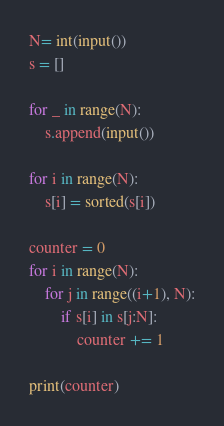Convert code to text. <code><loc_0><loc_0><loc_500><loc_500><_Python_>N= int(input())
s = []

for _ in range(N):
    s.append(input())

for i in range(N):
    s[i] = sorted(s[i])

counter = 0
for i in range(N):
    for j in range((i+1), N):
        if s[i] in s[j:N]:
            counter += 1

print(counter)  </code> 